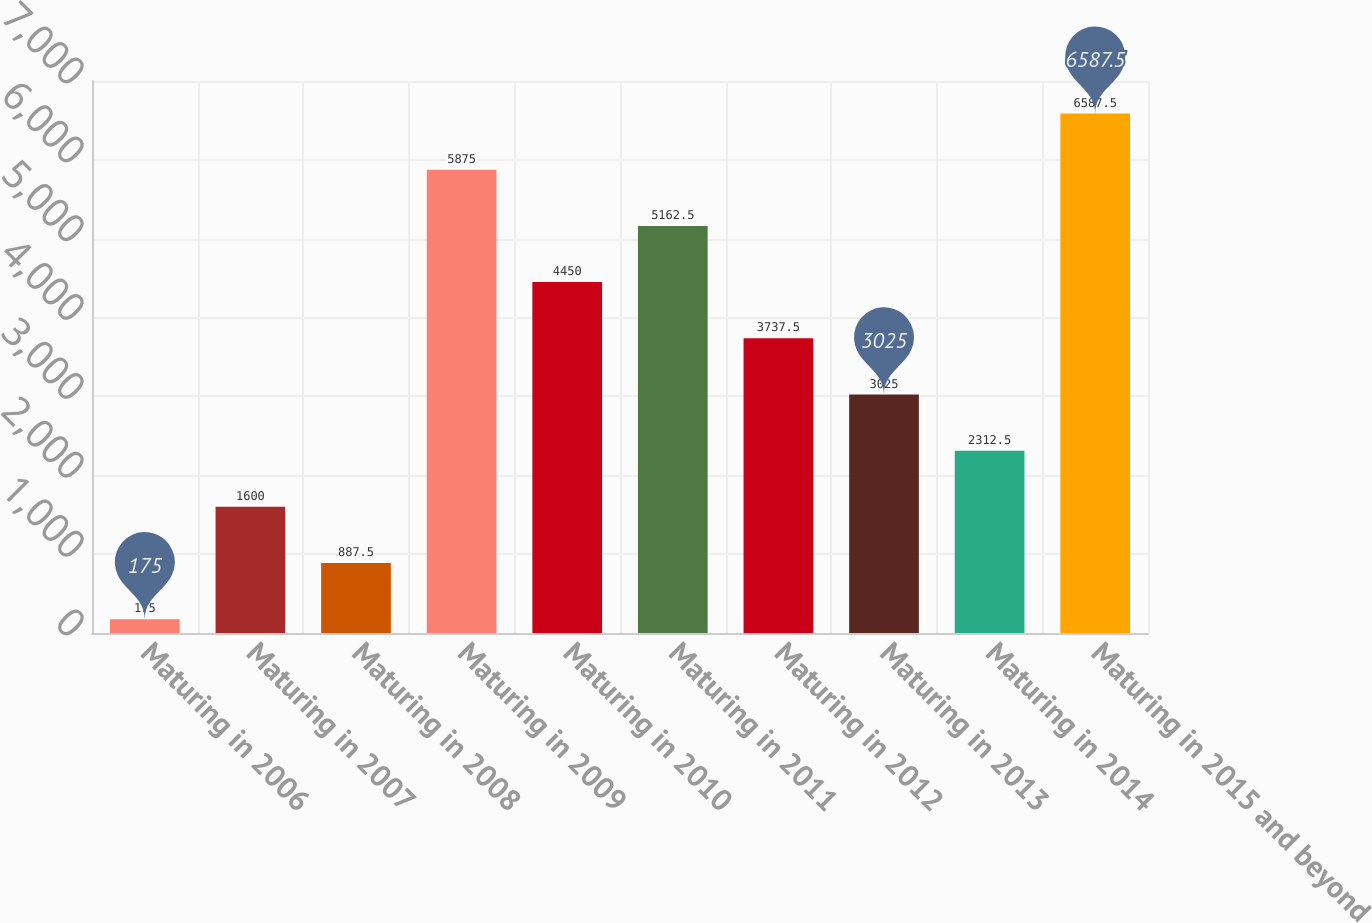<chart> <loc_0><loc_0><loc_500><loc_500><bar_chart><fcel>Maturing in 2006<fcel>Maturing in 2007<fcel>Maturing in 2008<fcel>Maturing in 2009<fcel>Maturing in 2010<fcel>Maturing in 2011<fcel>Maturing in 2012<fcel>Maturing in 2013<fcel>Maturing in 2014<fcel>Maturing in 2015 and beyond<nl><fcel>175<fcel>1600<fcel>887.5<fcel>5875<fcel>4450<fcel>5162.5<fcel>3737.5<fcel>3025<fcel>2312.5<fcel>6587.5<nl></chart> 